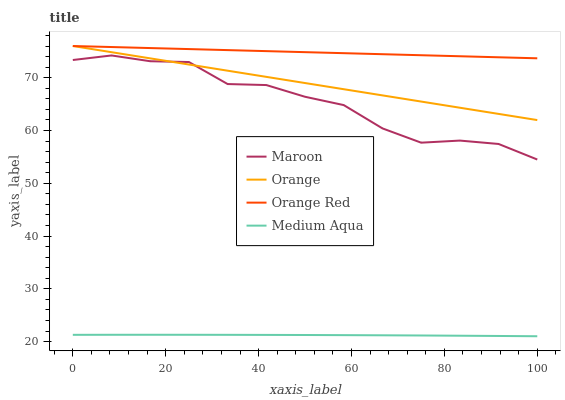Does Medium Aqua have the minimum area under the curve?
Answer yes or no. Yes. Does Orange Red have the maximum area under the curve?
Answer yes or no. Yes. Does Orange Red have the minimum area under the curve?
Answer yes or no. No. Does Medium Aqua have the maximum area under the curve?
Answer yes or no. No. Is Orange Red the smoothest?
Answer yes or no. Yes. Is Maroon the roughest?
Answer yes or no. Yes. Is Medium Aqua the smoothest?
Answer yes or no. No. Is Medium Aqua the roughest?
Answer yes or no. No. Does Medium Aqua have the lowest value?
Answer yes or no. Yes. Does Orange Red have the lowest value?
Answer yes or no. No. Does Orange Red have the highest value?
Answer yes or no. Yes. Does Medium Aqua have the highest value?
Answer yes or no. No. Is Medium Aqua less than Orange?
Answer yes or no. Yes. Is Orange greater than Medium Aqua?
Answer yes or no. Yes. Does Orange Red intersect Orange?
Answer yes or no. Yes. Is Orange Red less than Orange?
Answer yes or no. No. Is Orange Red greater than Orange?
Answer yes or no. No. Does Medium Aqua intersect Orange?
Answer yes or no. No. 